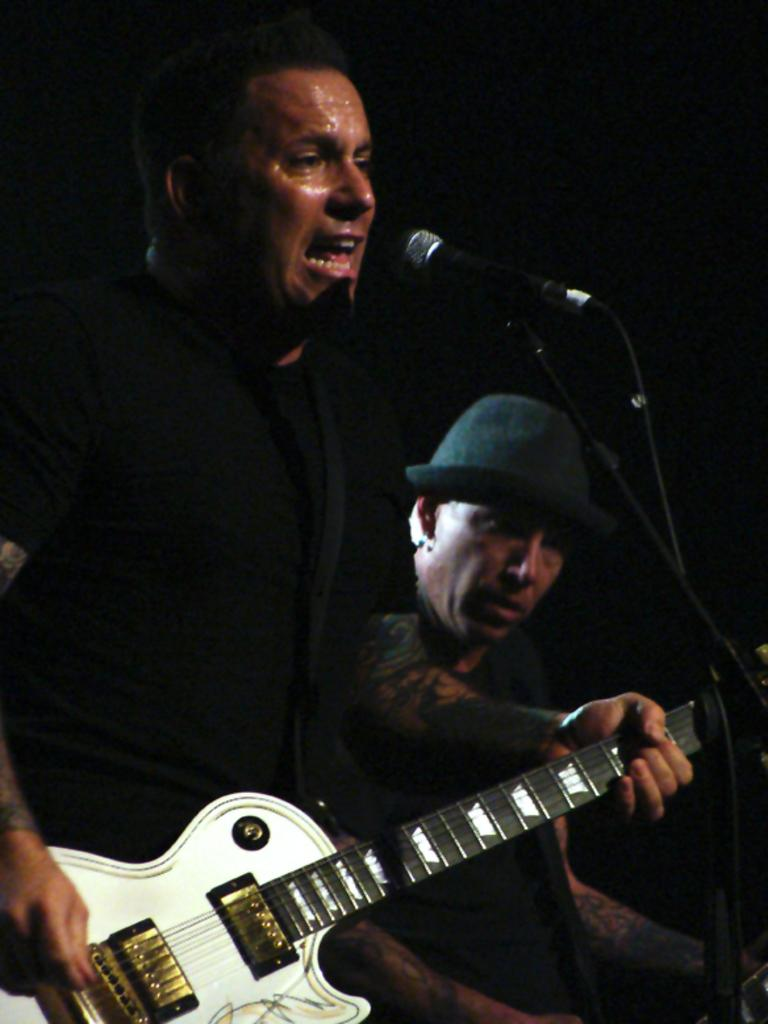What is the man in the image doing? The man is playing a guitar and singing a song. What object is the man using to amplify his voice? There is a microphone in the image. How many people are present in the image? There are two people in the image: the man playing the guitar and singing, and a person sitting and listening to the music. What type of wound can be seen on the guitar in the image? There is no wound visible on the guitar in the image. Is there a table present in the image? No, there is no table present in the image. 